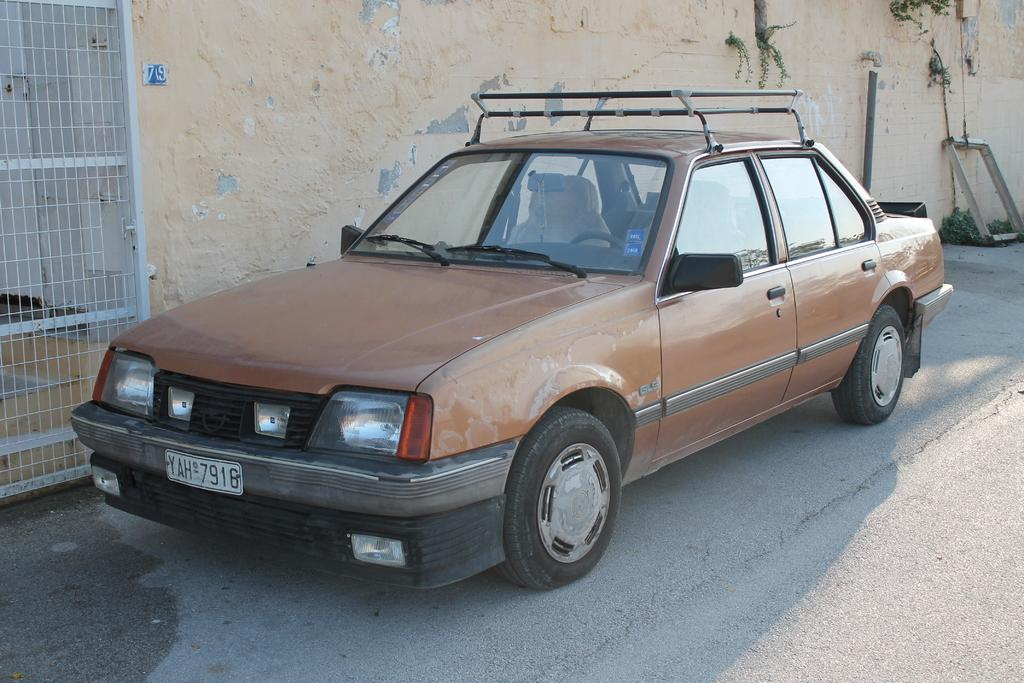What is the main subject of the picture? The main subject of the picture is a car. Where is the car located in the image? The car is parked on the road in the image. What features can be seen on the car? The car has headlights, a number plate, and a door. What can be seen in the background of the picture? There is a wall and a gate in the background of the picture. What type of kettle can be seen boiling water in the image? There is no kettle present in the image; it features a parked car on the road. How many trees are visible in the image? There are no trees visible in the image. 